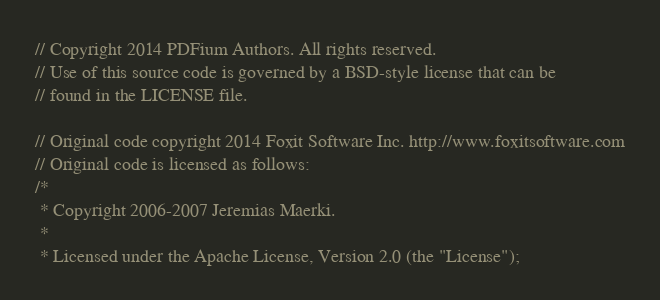Convert code to text. <code><loc_0><loc_0><loc_500><loc_500><_C++_>// Copyright 2014 PDFium Authors. All rights reserved.
// Use of this source code is governed by a BSD-style license that can be
// found in the LICENSE file.

// Original code copyright 2014 Foxit Software Inc. http://www.foxitsoftware.com
// Original code is licensed as follows:
/*
 * Copyright 2006-2007 Jeremias Maerki.
 *
 * Licensed under the Apache License, Version 2.0 (the "License");</code> 